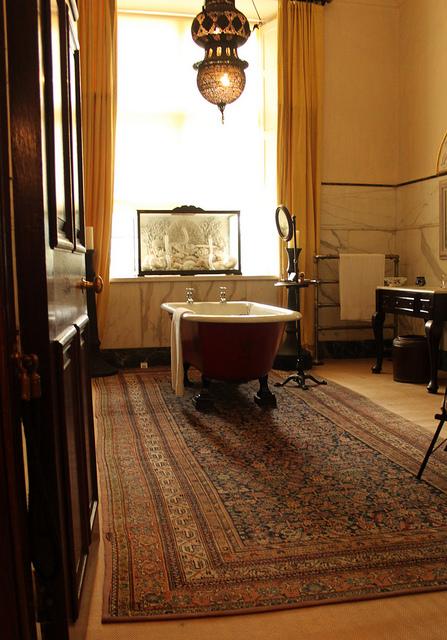Can you see a bathtub in the room?
Short answer required. Yes. What is the bathtub on?
Give a very brief answer. Rug. What color is the door?
Keep it brief. Brown. 